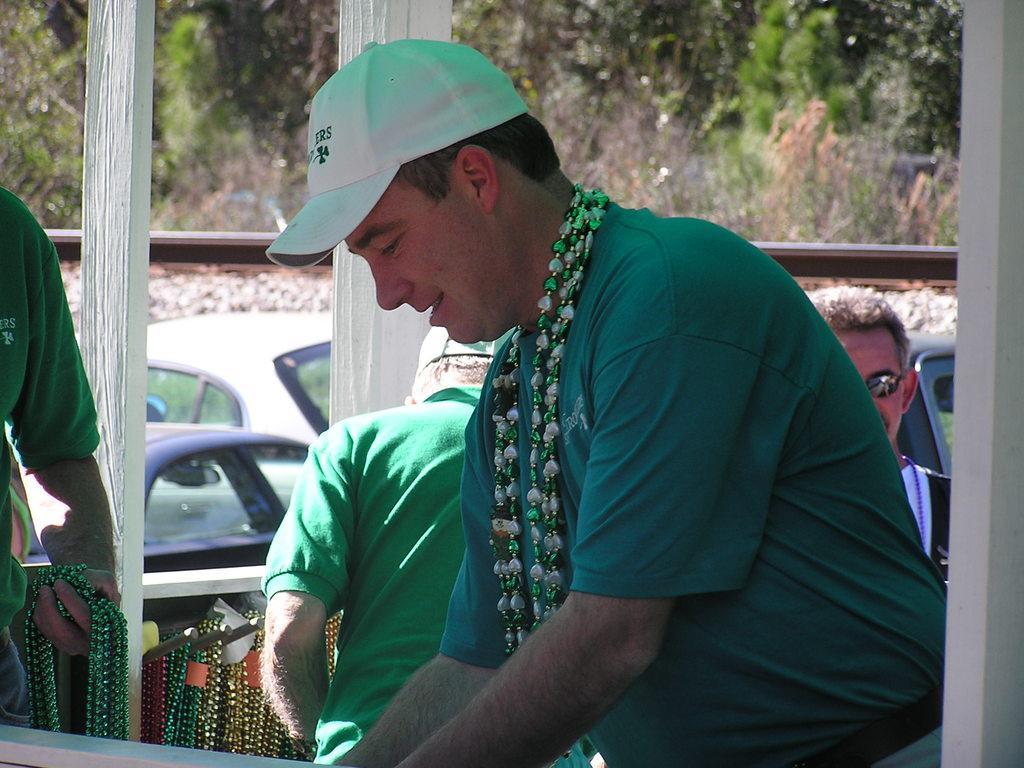Could you give a brief overview of what you see in this image? In the middle of the image we can see a man and he wore a cap. In the background we can see people, vehicles, poles, trees, and other objects. 